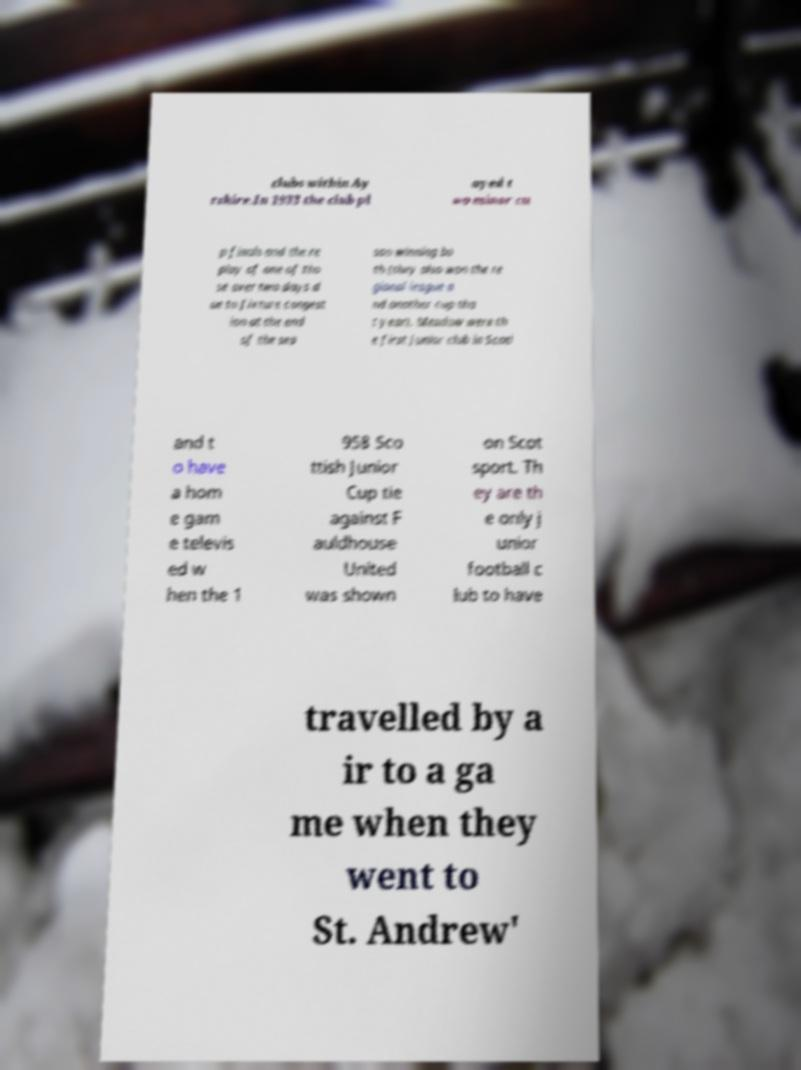What messages or text are displayed in this image? I need them in a readable, typed format. clubs within Ay rshire.In 1933 the club pl ayed t wo minor cu p finals and the re play of one of tho se over two days d ue to fixture congest ion at the end of the sea son winning bo th (they also won the re gional league a nd another cup tha t year). Meadow were th e first junior club in Scotl and t o have a hom e gam e televis ed w hen the 1 958 Sco ttish Junior Cup tie against F auldhouse United was shown on Scot sport. Th ey are th e only j unior football c lub to have travelled by a ir to a ga me when they went to St. Andrew' 